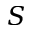<formula> <loc_0><loc_0><loc_500><loc_500>S</formula> 